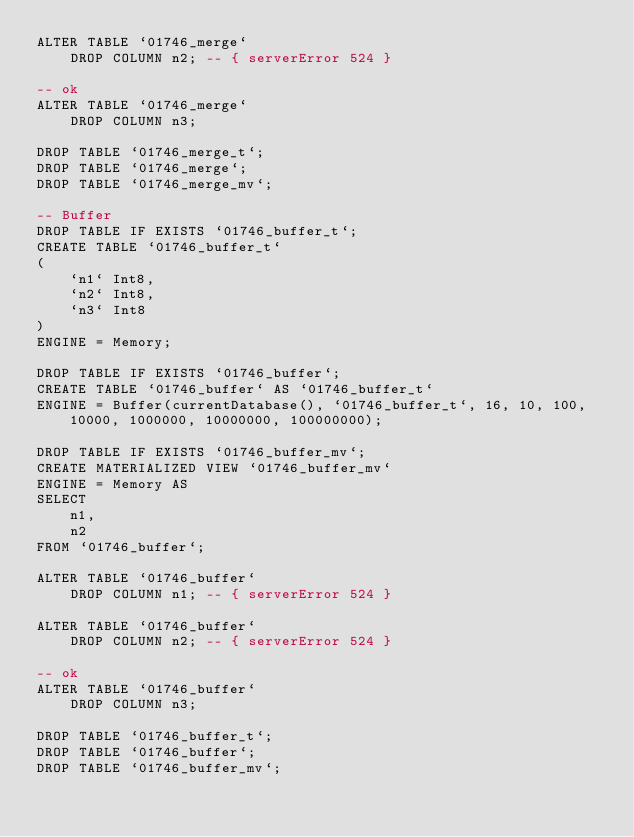Convert code to text. <code><loc_0><loc_0><loc_500><loc_500><_SQL_>ALTER TABLE `01746_merge`
    DROP COLUMN n2; -- { serverError 524 }

-- ok
ALTER TABLE `01746_merge`
    DROP COLUMN n3;

DROP TABLE `01746_merge_t`;
DROP TABLE `01746_merge`;
DROP TABLE `01746_merge_mv`;

-- Buffer
DROP TABLE IF EXISTS `01746_buffer_t`;
CREATE TABLE `01746_buffer_t`
(
    `n1` Int8,
    `n2` Int8,
    `n3` Int8
)
ENGINE = Memory;

DROP TABLE IF EXISTS `01746_buffer`;
CREATE TABLE `01746_buffer` AS `01746_buffer_t`
ENGINE = Buffer(currentDatabase(), `01746_buffer_t`, 16, 10, 100, 10000, 1000000, 10000000, 100000000);

DROP TABLE IF EXISTS `01746_buffer_mv`;
CREATE MATERIALIZED VIEW `01746_buffer_mv`
ENGINE = Memory AS
SELECT
    n1,
    n2
FROM `01746_buffer`;

ALTER TABLE `01746_buffer`
    DROP COLUMN n1; -- { serverError 524 }

ALTER TABLE `01746_buffer`
    DROP COLUMN n2; -- { serverError 524 }

-- ok
ALTER TABLE `01746_buffer`
    DROP COLUMN n3;

DROP TABLE `01746_buffer_t`;
DROP TABLE `01746_buffer`;
DROP TABLE `01746_buffer_mv`;
</code> 